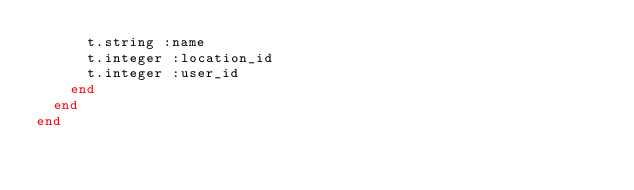<code> <loc_0><loc_0><loc_500><loc_500><_Ruby_>      t.string :name
      t.integer :location_id
      t.integer :user_id
    end
  end
end
</code> 